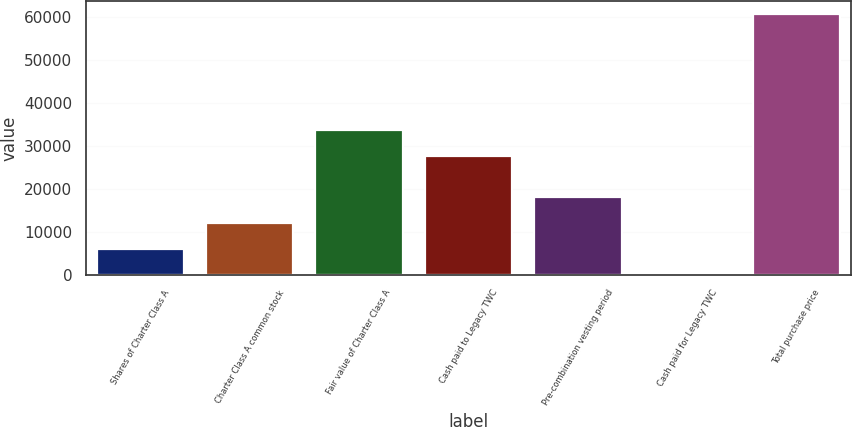<chart> <loc_0><loc_0><loc_500><loc_500><bar_chart><fcel>Shares of Charter Class A<fcel>Charter Class A common stock<fcel>Fair value of Charter Class A<fcel>Cash paid to Legacy TWC<fcel>Pre-combination vesting period<fcel>Cash paid for Legacy TWC<fcel>Total purchase price<nl><fcel>6113.8<fcel>12158.6<fcel>33814.8<fcel>27770<fcel>18203.4<fcel>69<fcel>60517<nl></chart> 